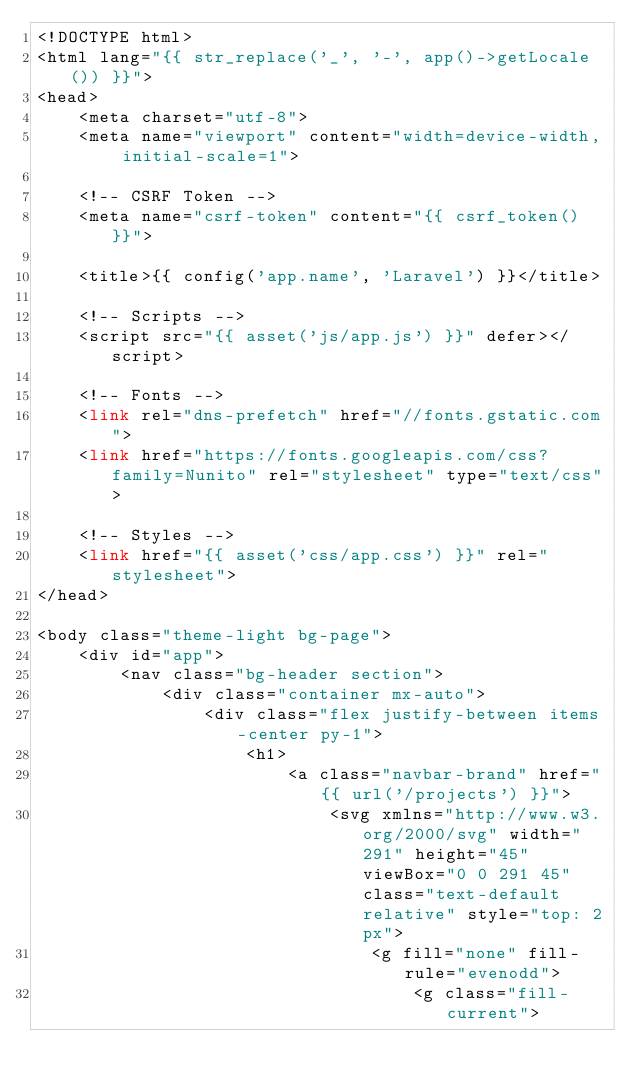<code> <loc_0><loc_0><loc_500><loc_500><_PHP_><!DOCTYPE html>
<html lang="{{ str_replace('_', '-', app()->getLocale()) }}">
<head>
    <meta charset="utf-8">
    <meta name="viewport" content="width=device-width, initial-scale=1">

    <!-- CSRF Token -->
    <meta name="csrf-token" content="{{ csrf_token() }}">

    <title>{{ config('app.name', 'Laravel') }}</title>

    <!-- Scripts -->
    <script src="{{ asset('js/app.js') }}" defer></script>

    <!-- Fonts -->
    <link rel="dns-prefetch" href="//fonts.gstatic.com">
    <link href="https://fonts.googleapis.com/css?family=Nunito" rel="stylesheet" type="text/css">

    <!-- Styles -->
    <link href="{{ asset('css/app.css') }}" rel="stylesheet">
</head>

<body class="theme-light bg-page">
    <div id="app">
        <nav class="bg-header section">
            <div class="container mx-auto">
                <div class="flex justify-between items-center py-1">
                    <h1>
                        <a class="navbar-brand" href="{{ url('/projects') }}">
                            <svg xmlns="http://www.w3.org/2000/svg" width="291" height="45" viewBox="0 0 291 45" class="text-default relative" style="top: 2px">
                                <g fill="none" fill-rule="evenodd">
                                    <g class="fill-current"></code> 